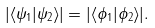Convert formula to latex. <formula><loc_0><loc_0><loc_500><loc_500>| \langle \psi _ { 1 } | \psi _ { 2 } \rangle | = | \langle \phi _ { 1 } | \phi _ { 2 } \rangle | .</formula> 